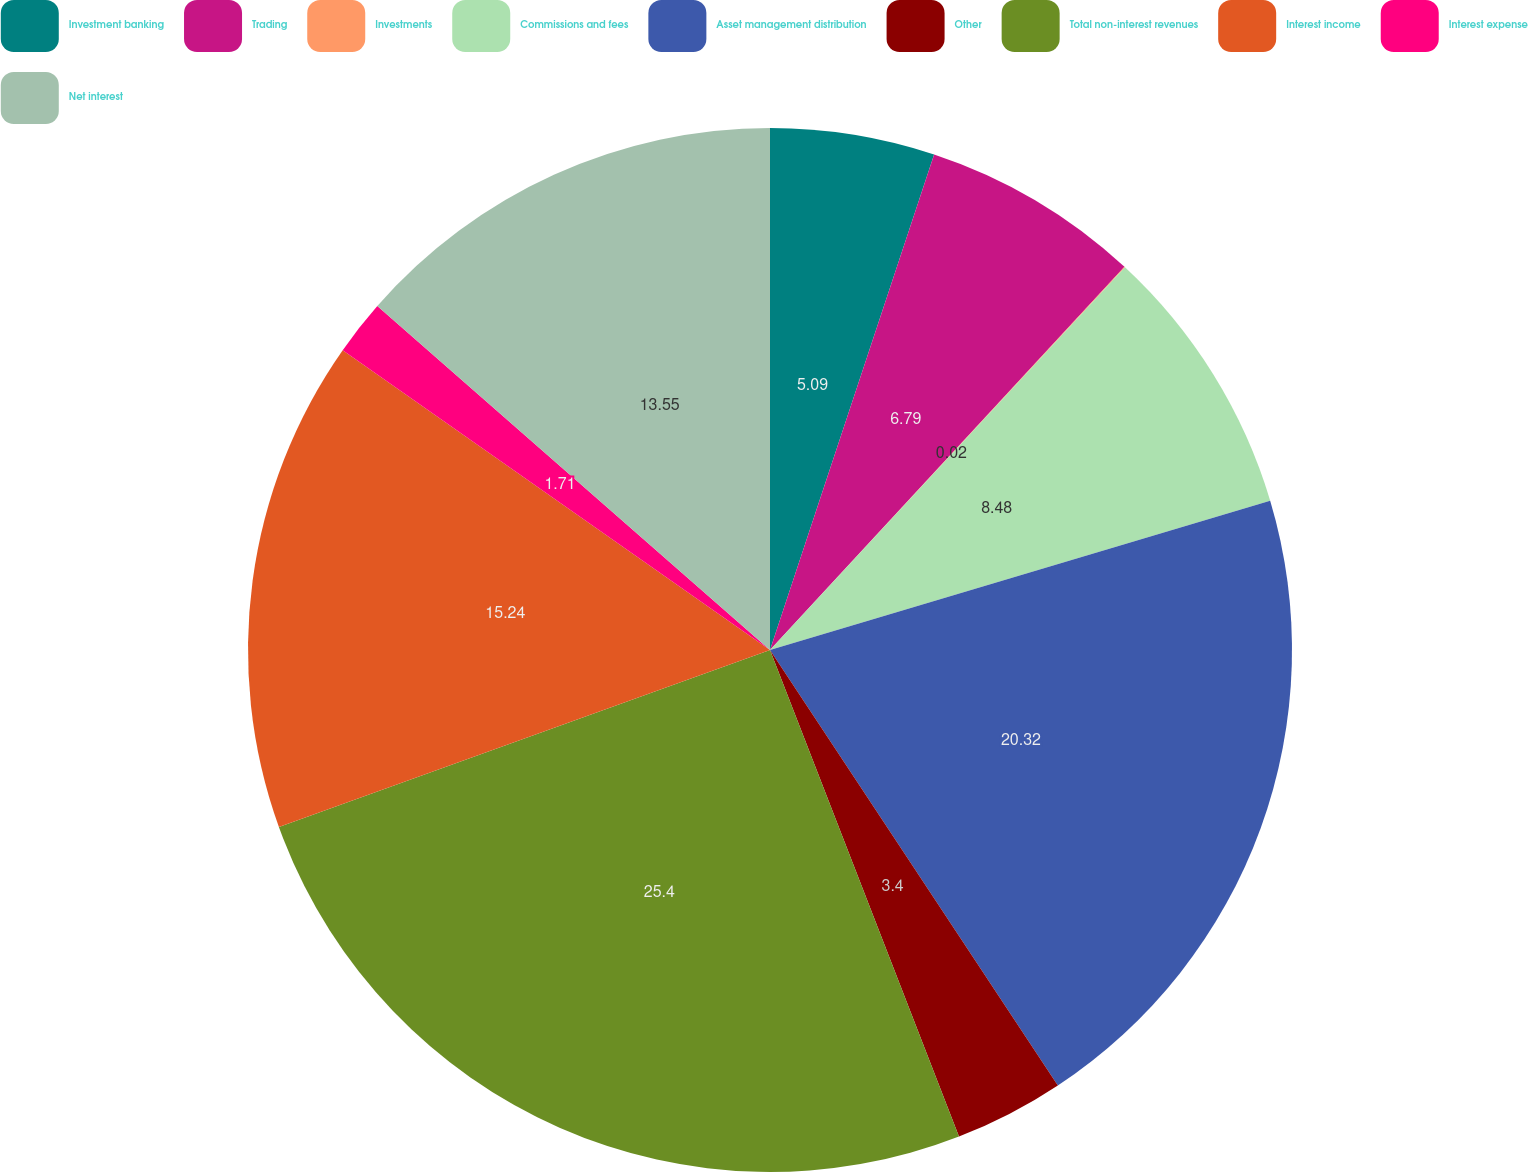Convert chart to OTSL. <chart><loc_0><loc_0><loc_500><loc_500><pie_chart><fcel>Investment banking<fcel>Trading<fcel>Investments<fcel>Commissions and fees<fcel>Asset management distribution<fcel>Other<fcel>Total non-interest revenues<fcel>Interest income<fcel>Interest expense<fcel>Net interest<nl><fcel>5.09%<fcel>6.79%<fcel>0.02%<fcel>8.48%<fcel>20.32%<fcel>3.4%<fcel>25.39%<fcel>15.24%<fcel>1.71%<fcel>13.55%<nl></chart> 